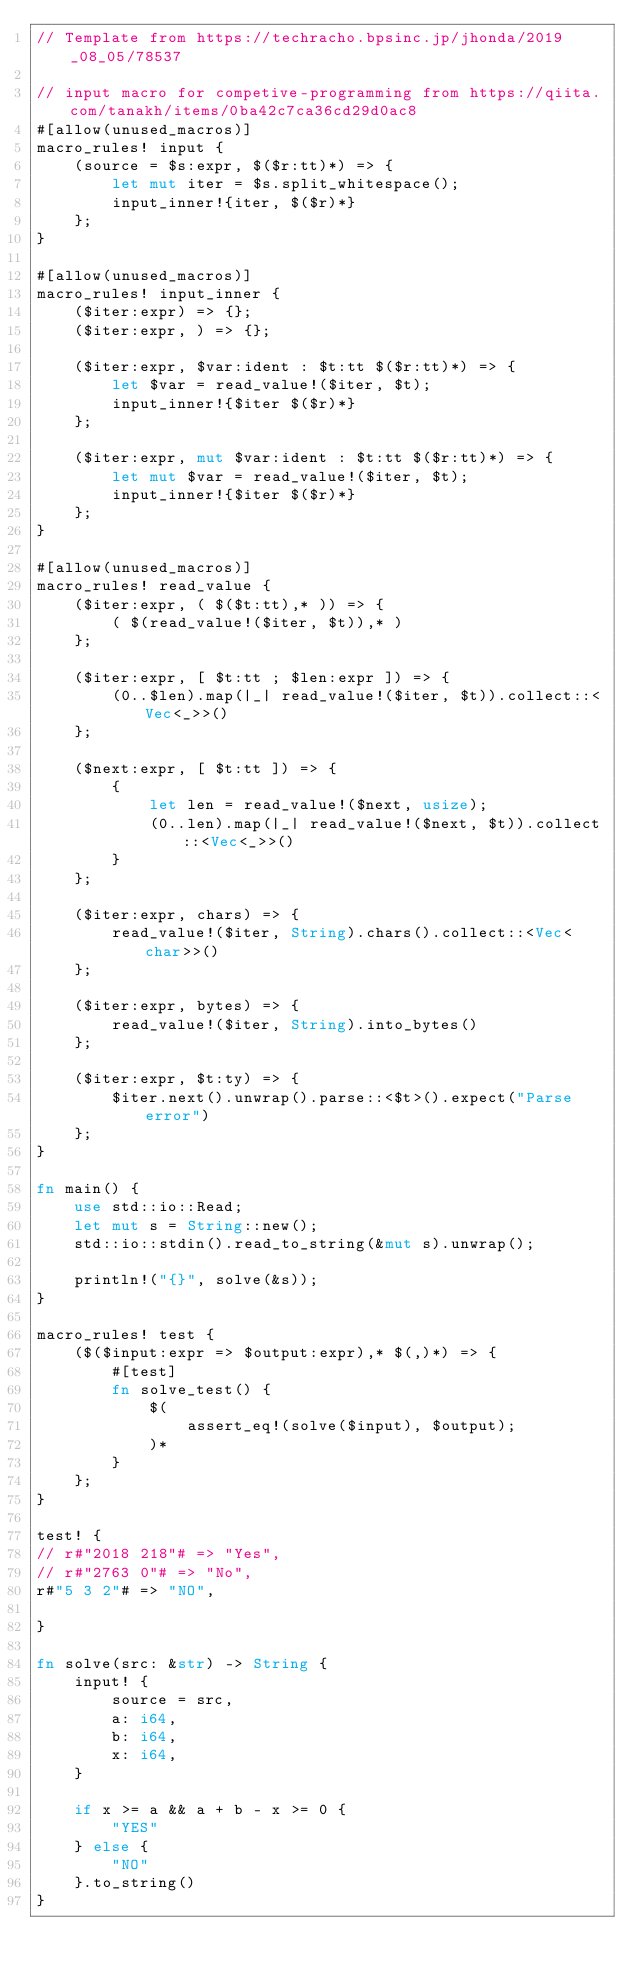Convert code to text. <code><loc_0><loc_0><loc_500><loc_500><_Rust_>// Template from https://techracho.bpsinc.jp/jhonda/2019_08_05/78537

// input macro for competive-programming from https://qiita.com/tanakh/items/0ba42c7ca36cd29d0ac8
#[allow(unused_macros)]
macro_rules! input {
    (source = $s:expr, $($r:tt)*) => {
        let mut iter = $s.split_whitespace();
        input_inner!{iter, $($r)*}
    };
}

#[allow(unused_macros)]
macro_rules! input_inner {
    ($iter:expr) => {};
    ($iter:expr, ) => {};

    ($iter:expr, $var:ident : $t:tt $($r:tt)*) => {
        let $var = read_value!($iter, $t);
        input_inner!{$iter $($r)*}
    };

    ($iter:expr, mut $var:ident : $t:tt $($r:tt)*) => {
        let mut $var = read_value!($iter, $t);
        input_inner!{$iter $($r)*}
    };
}

#[allow(unused_macros)]
macro_rules! read_value {
    ($iter:expr, ( $($t:tt),* )) => {
        ( $(read_value!($iter, $t)),* )
    };

    ($iter:expr, [ $t:tt ; $len:expr ]) => {
        (0..$len).map(|_| read_value!($iter, $t)).collect::<Vec<_>>()
    };

    ($next:expr, [ $t:tt ]) => {
        {
            let len = read_value!($next, usize);
            (0..len).map(|_| read_value!($next, $t)).collect::<Vec<_>>()
        }
    };

    ($iter:expr, chars) => {
        read_value!($iter, String).chars().collect::<Vec<char>>()
    };

    ($iter:expr, bytes) => {
        read_value!($iter, String).into_bytes()
    };

    ($iter:expr, $t:ty) => {
        $iter.next().unwrap().parse::<$t>().expect("Parse error")
    };
}

fn main() {
    use std::io::Read;
    let mut s = String::new();
    std::io::stdin().read_to_string(&mut s).unwrap();

    println!("{}", solve(&s));
}

macro_rules! test {
    ($($input:expr => $output:expr),* $(,)*) => {
        #[test]
        fn solve_test() {
            $(
                assert_eq!(solve($input), $output);
            )*
        }
    };
}

test! {
// r#"2018 218"# => "Yes",
// r#"2763 0"# => "No",
r#"5 3 2"# => "NO",

}

fn solve(src: &str) -> String {
    input! {
        source = src,
        a: i64,
        b: i64,
        x: i64,
    }

    if x >= a && a + b - x >= 0 {
        "YES"
    } else {
        "NO"
    }.to_string()
}</code> 